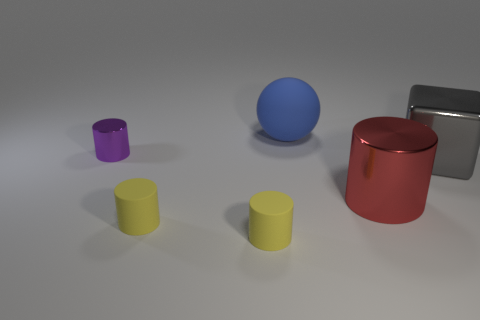Subtract all yellow cylinders. How many were subtracted if there are1yellow cylinders left? 1 Subtract 1 cylinders. How many cylinders are left? 3 Add 1 purple things. How many objects exist? 7 Subtract all spheres. How many objects are left? 5 Subtract all red metal cylinders. Subtract all tiny purple cylinders. How many objects are left? 4 Add 2 red objects. How many red objects are left? 3 Add 6 big matte spheres. How many big matte spheres exist? 7 Subtract 0 brown blocks. How many objects are left? 6 